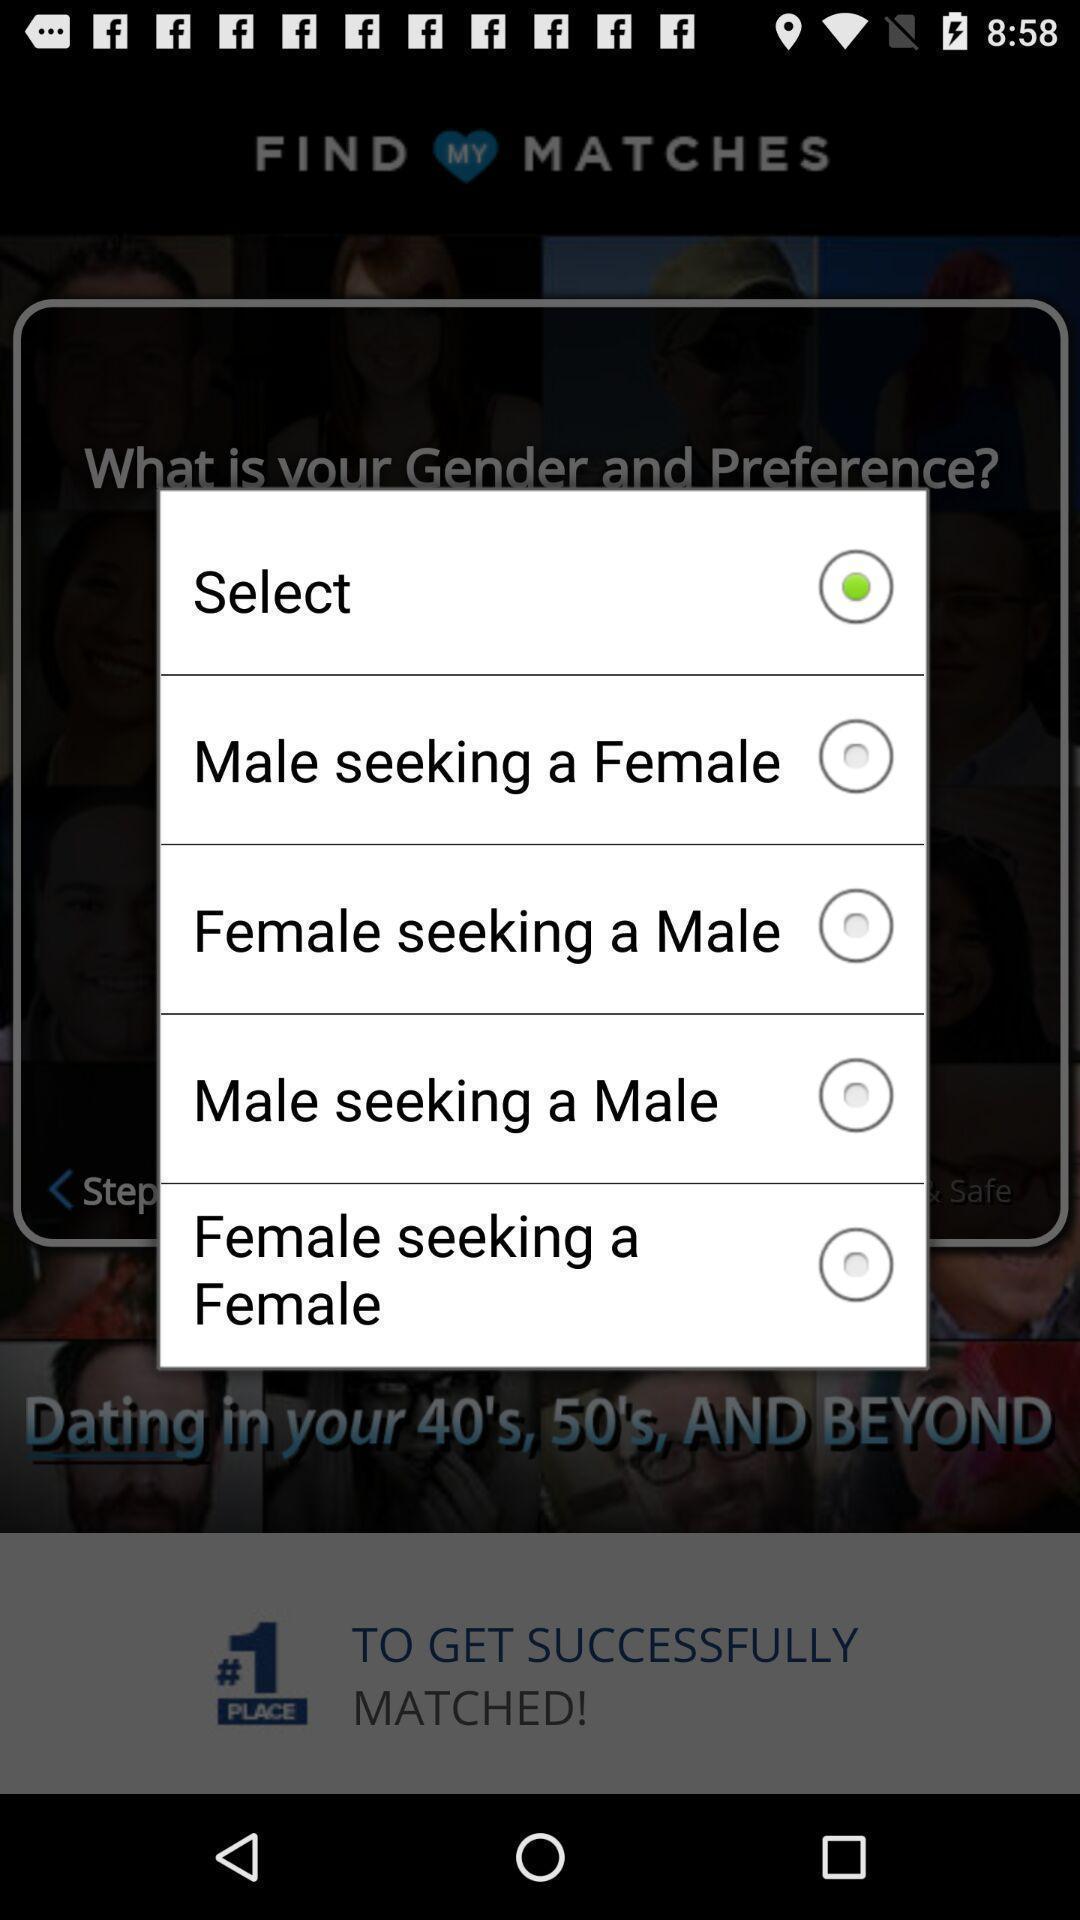Provide a textual representation of this image. Pop-up to select seeking option in the application. 